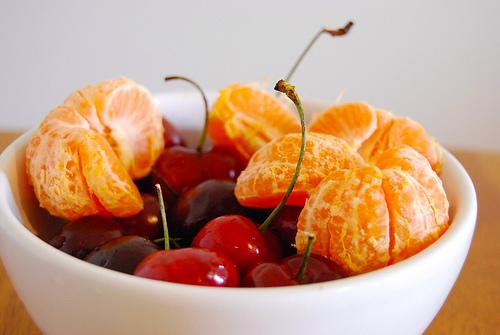What is contained in the red fruit that should not be ingested?

Choices:
A) skin
B) sticks
C) juice
D) seed seed 